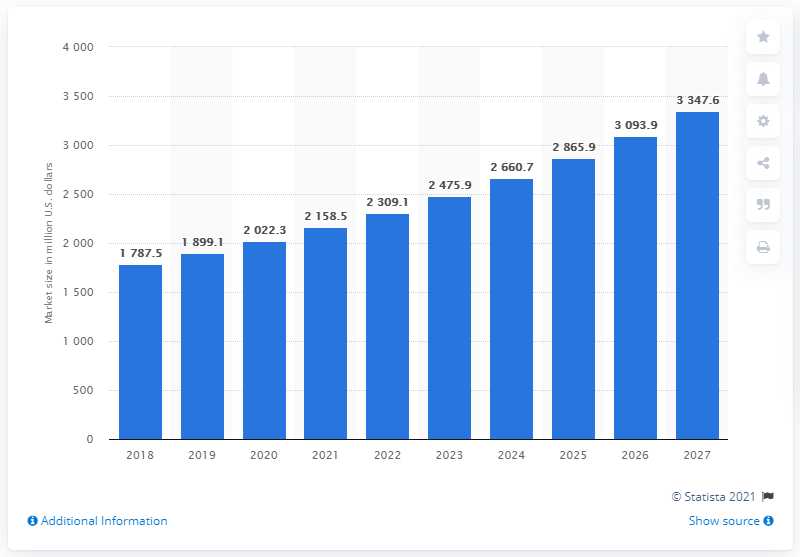Give some essential details in this illustration. In 2018, the global market for immunohistochemistry was worth approximately 1,787.5 million dollars. 